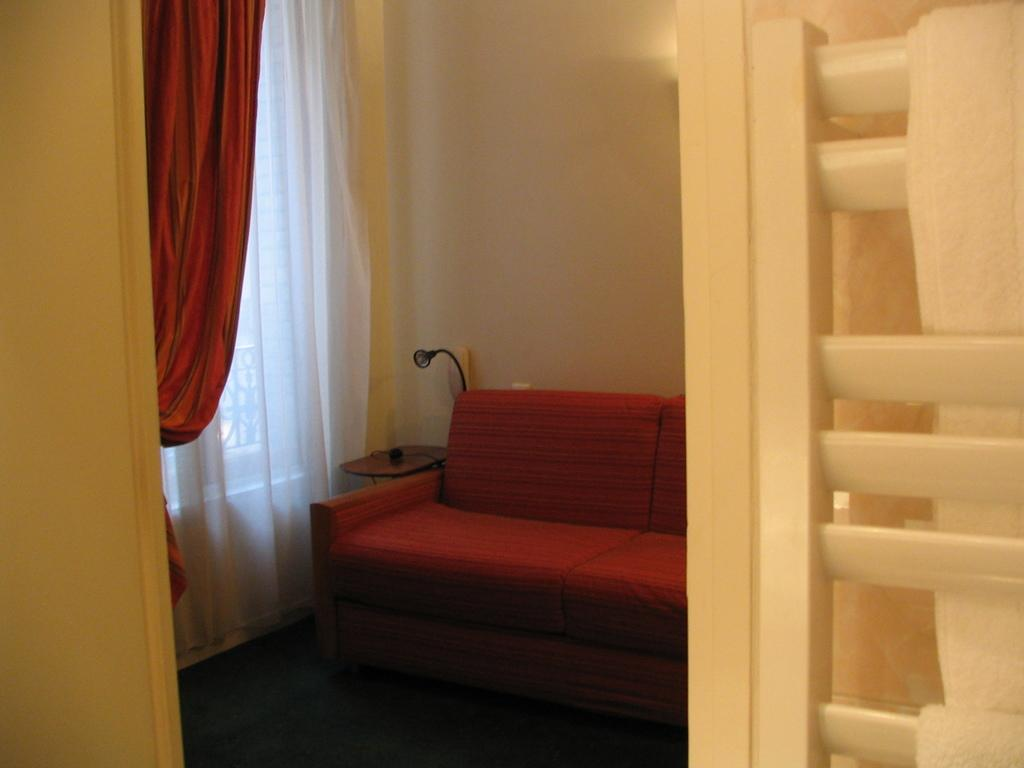What type of furniture is in the room? There is a sofa in the room. What type of window treatment is present in the room? There are curtains in the room. How many snakes are crawling on the sofa in the room? There are no snakes present in the room; only a sofa and curtains are mentioned. What color is the kite hanging from the ceiling in the room? There is no mention of a kite in the room; only a sofa and curtains are described. 